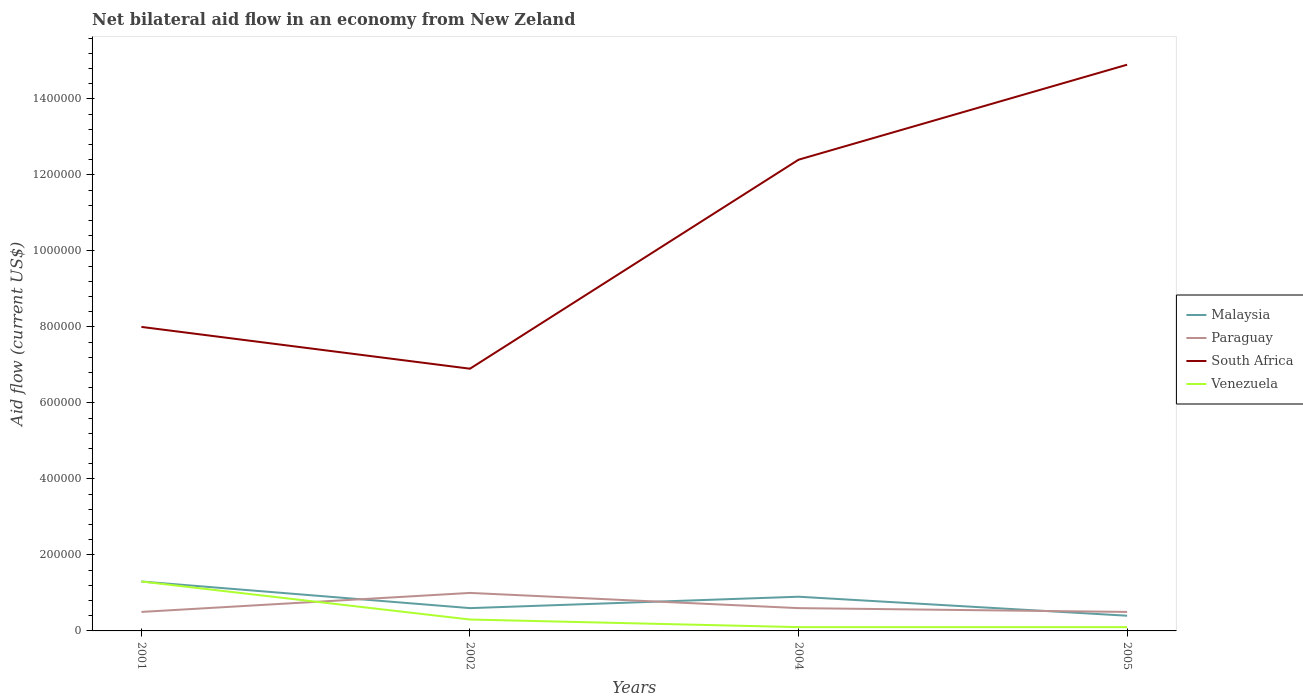Across all years, what is the maximum net bilateral aid flow in South Africa?
Give a very brief answer. 6.90e+05. What is the difference between the highest and the second highest net bilateral aid flow in Malaysia?
Ensure brevity in your answer.  9.00e+04. What is the difference between the highest and the lowest net bilateral aid flow in Paraguay?
Your answer should be very brief. 1. Is the net bilateral aid flow in Venezuela strictly greater than the net bilateral aid flow in Malaysia over the years?
Your response must be concise. No. How many years are there in the graph?
Your response must be concise. 4. Does the graph contain any zero values?
Offer a very short reply. No. Does the graph contain grids?
Offer a very short reply. No. Where does the legend appear in the graph?
Ensure brevity in your answer.  Center right. What is the title of the graph?
Your answer should be very brief. Net bilateral aid flow in an economy from New Zeland. What is the Aid flow (current US$) in Malaysia in 2001?
Offer a very short reply. 1.30e+05. What is the Aid flow (current US$) of Paraguay in 2001?
Your answer should be compact. 5.00e+04. What is the Aid flow (current US$) of South Africa in 2001?
Offer a terse response. 8.00e+05. What is the Aid flow (current US$) of Venezuela in 2001?
Your response must be concise. 1.30e+05. What is the Aid flow (current US$) in Malaysia in 2002?
Offer a very short reply. 6.00e+04. What is the Aid flow (current US$) in Paraguay in 2002?
Offer a very short reply. 1.00e+05. What is the Aid flow (current US$) in South Africa in 2002?
Your response must be concise. 6.90e+05. What is the Aid flow (current US$) of Venezuela in 2002?
Your answer should be compact. 3.00e+04. What is the Aid flow (current US$) in South Africa in 2004?
Make the answer very short. 1.24e+06. What is the Aid flow (current US$) of Venezuela in 2004?
Ensure brevity in your answer.  10000. What is the Aid flow (current US$) of Paraguay in 2005?
Your answer should be compact. 5.00e+04. What is the Aid flow (current US$) of South Africa in 2005?
Make the answer very short. 1.49e+06. What is the Aid flow (current US$) in Venezuela in 2005?
Keep it short and to the point. 10000. Across all years, what is the maximum Aid flow (current US$) of South Africa?
Keep it short and to the point. 1.49e+06. Across all years, what is the minimum Aid flow (current US$) in South Africa?
Make the answer very short. 6.90e+05. What is the total Aid flow (current US$) of Malaysia in the graph?
Keep it short and to the point. 3.20e+05. What is the total Aid flow (current US$) of Paraguay in the graph?
Make the answer very short. 2.60e+05. What is the total Aid flow (current US$) in South Africa in the graph?
Offer a very short reply. 4.22e+06. What is the total Aid flow (current US$) in Venezuela in the graph?
Your response must be concise. 1.80e+05. What is the difference between the Aid flow (current US$) in Venezuela in 2001 and that in 2002?
Provide a succinct answer. 1.00e+05. What is the difference between the Aid flow (current US$) in Paraguay in 2001 and that in 2004?
Provide a short and direct response. -10000. What is the difference between the Aid flow (current US$) in South Africa in 2001 and that in 2004?
Provide a short and direct response. -4.40e+05. What is the difference between the Aid flow (current US$) of Venezuela in 2001 and that in 2004?
Offer a terse response. 1.20e+05. What is the difference between the Aid flow (current US$) in South Africa in 2001 and that in 2005?
Provide a short and direct response. -6.90e+05. What is the difference between the Aid flow (current US$) of Venezuela in 2001 and that in 2005?
Ensure brevity in your answer.  1.20e+05. What is the difference between the Aid flow (current US$) in Paraguay in 2002 and that in 2004?
Your answer should be compact. 4.00e+04. What is the difference between the Aid flow (current US$) of South Africa in 2002 and that in 2004?
Make the answer very short. -5.50e+05. What is the difference between the Aid flow (current US$) in Venezuela in 2002 and that in 2004?
Your response must be concise. 2.00e+04. What is the difference between the Aid flow (current US$) in South Africa in 2002 and that in 2005?
Offer a very short reply. -8.00e+05. What is the difference between the Aid flow (current US$) in Malaysia in 2001 and the Aid flow (current US$) in Paraguay in 2002?
Provide a succinct answer. 3.00e+04. What is the difference between the Aid flow (current US$) of Malaysia in 2001 and the Aid flow (current US$) of South Africa in 2002?
Make the answer very short. -5.60e+05. What is the difference between the Aid flow (current US$) in Malaysia in 2001 and the Aid flow (current US$) in Venezuela in 2002?
Offer a very short reply. 1.00e+05. What is the difference between the Aid flow (current US$) in Paraguay in 2001 and the Aid flow (current US$) in South Africa in 2002?
Offer a terse response. -6.40e+05. What is the difference between the Aid flow (current US$) of Paraguay in 2001 and the Aid flow (current US$) of Venezuela in 2002?
Your answer should be very brief. 2.00e+04. What is the difference between the Aid flow (current US$) in South Africa in 2001 and the Aid flow (current US$) in Venezuela in 2002?
Offer a very short reply. 7.70e+05. What is the difference between the Aid flow (current US$) of Malaysia in 2001 and the Aid flow (current US$) of South Africa in 2004?
Provide a succinct answer. -1.11e+06. What is the difference between the Aid flow (current US$) in Paraguay in 2001 and the Aid flow (current US$) in South Africa in 2004?
Your answer should be compact. -1.19e+06. What is the difference between the Aid flow (current US$) in Paraguay in 2001 and the Aid flow (current US$) in Venezuela in 2004?
Offer a terse response. 4.00e+04. What is the difference between the Aid flow (current US$) in South Africa in 2001 and the Aid flow (current US$) in Venezuela in 2004?
Provide a short and direct response. 7.90e+05. What is the difference between the Aid flow (current US$) in Malaysia in 2001 and the Aid flow (current US$) in Paraguay in 2005?
Provide a succinct answer. 8.00e+04. What is the difference between the Aid flow (current US$) in Malaysia in 2001 and the Aid flow (current US$) in South Africa in 2005?
Make the answer very short. -1.36e+06. What is the difference between the Aid flow (current US$) in Malaysia in 2001 and the Aid flow (current US$) in Venezuela in 2005?
Provide a succinct answer. 1.20e+05. What is the difference between the Aid flow (current US$) of Paraguay in 2001 and the Aid flow (current US$) of South Africa in 2005?
Provide a succinct answer. -1.44e+06. What is the difference between the Aid flow (current US$) of Paraguay in 2001 and the Aid flow (current US$) of Venezuela in 2005?
Your answer should be very brief. 4.00e+04. What is the difference between the Aid flow (current US$) of South Africa in 2001 and the Aid flow (current US$) of Venezuela in 2005?
Ensure brevity in your answer.  7.90e+05. What is the difference between the Aid flow (current US$) in Malaysia in 2002 and the Aid flow (current US$) in South Africa in 2004?
Your answer should be very brief. -1.18e+06. What is the difference between the Aid flow (current US$) in Paraguay in 2002 and the Aid flow (current US$) in South Africa in 2004?
Your answer should be compact. -1.14e+06. What is the difference between the Aid flow (current US$) of South Africa in 2002 and the Aid flow (current US$) of Venezuela in 2004?
Your answer should be compact. 6.80e+05. What is the difference between the Aid flow (current US$) in Malaysia in 2002 and the Aid flow (current US$) in South Africa in 2005?
Give a very brief answer. -1.43e+06. What is the difference between the Aid flow (current US$) in Malaysia in 2002 and the Aid flow (current US$) in Venezuela in 2005?
Your response must be concise. 5.00e+04. What is the difference between the Aid flow (current US$) in Paraguay in 2002 and the Aid flow (current US$) in South Africa in 2005?
Provide a short and direct response. -1.39e+06. What is the difference between the Aid flow (current US$) in Paraguay in 2002 and the Aid flow (current US$) in Venezuela in 2005?
Provide a succinct answer. 9.00e+04. What is the difference between the Aid flow (current US$) of South Africa in 2002 and the Aid flow (current US$) of Venezuela in 2005?
Provide a succinct answer. 6.80e+05. What is the difference between the Aid flow (current US$) of Malaysia in 2004 and the Aid flow (current US$) of Paraguay in 2005?
Provide a short and direct response. 4.00e+04. What is the difference between the Aid flow (current US$) in Malaysia in 2004 and the Aid flow (current US$) in South Africa in 2005?
Provide a succinct answer. -1.40e+06. What is the difference between the Aid flow (current US$) in Paraguay in 2004 and the Aid flow (current US$) in South Africa in 2005?
Offer a very short reply. -1.43e+06. What is the difference between the Aid flow (current US$) in South Africa in 2004 and the Aid flow (current US$) in Venezuela in 2005?
Give a very brief answer. 1.23e+06. What is the average Aid flow (current US$) of Malaysia per year?
Offer a very short reply. 8.00e+04. What is the average Aid flow (current US$) of Paraguay per year?
Ensure brevity in your answer.  6.50e+04. What is the average Aid flow (current US$) of South Africa per year?
Offer a terse response. 1.06e+06. What is the average Aid flow (current US$) of Venezuela per year?
Offer a terse response. 4.50e+04. In the year 2001, what is the difference between the Aid flow (current US$) in Malaysia and Aid flow (current US$) in Paraguay?
Offer a very short reply. 8.00e+04. In the year 2001, what is the difference between the Aid flow (current US$) in Malaysia and Aid flow (current US$) in South Africa?
Make the answer very short. -6.70e+05. In the year 2001, what is the difference between the Aid flow (current US$) of Paraguay and Aid flow (current US$) of South Africa?
Offer a terse response. -7.50e+05. In the year 2001, what is the difference between the Aid flow (current US$) in Paraguay and Aid flow (current US$) in Venezuela?
Make the answer very short. -8.00e+04. In the year 2001, what is the difference between the Aid flow (current US$) in South Africa and Aid flow (current US$) in Venezuela?
Give a very brief answer. 6.70e+05. In the year 2002, what is the difference between the Aid flow (current US$) in Malaysia and Aid flow (current US$) in South Africa?
Make the answer very short. -6.30e+05. In the year 2002, what is the difference between the Aid flow (current US$) in Malaysia and Aid flow (current US$) in Venezuela?
Make the answer very short. 3.00e+04. In the year 2002, what is the difference between the Aid flow (current US$) in Paraguay and Aid flow (current US$) in South Africa?
Offer a very short reply. -5.90e+05. In the year 2004, what is the difference between the Aid flow (current US$) of Malaysia and Aid flow (current US$) of South Africa?
Your answer should be very brief. -1.15e+06. In the year 2004, what is the difference between the Aid flow (current US$) in Malaysia and Aid flow (current US$) in Venezuela?
Make the answer very short. 8.00e+04. In the year 2004, what is the difference between the Aid flow (current US$) in Paraguay and Aid flow (current US$) in South Africa?
Your answer should be very brief. -1.18e+06. In the year 2004, what is the difference between the Aid flow (current US$) in South Africa and Aid flow (current US$) in Venezuela?
Provide a succinct answer. 1.23e+06. In the year 2005, what is the difference between the Aid flow (current US$) in Malaysia and Aid flow (current US$) in Paraguay?
Make the answer very short. -10000. In the year 2005, what is the difference between the Aid flow (current US$) of Malaysia and Aid flow (current US$) of South Africa?
Your response must be concise. -1.45e+06. In the year 2005, what is the difference between the Aid flow (current US$) in Paraguay and Aid flow (current US$) in South Africa?
Your response must be concise. -1.44e+06. In the year 2005, what is the difference between the Aid flow (current US$) of Paraguay and Aid flow (current US$) of Venezuela?
Your answer should be compact. 4.00e+04. In the year 2005, what is the difference between the Aid flow (current US$) in South Africa and Aid flow (current US$) in Venezuela?
Give a very brief answer. 1.48e+06. What is the ratio of the Aid flow (current US$) of Malaysia in 2001 to that in 2002?
Ensure brevity in your answer.  2.17. What is the ratio of the Aid flow (current US$) of Paraguay in 2001 to that in 2002?
Offer a terse response. 0.5. What is the ratio of the Aid flow (current US$) of South Africa in 2001 to that in 2002?
Offer a terse response. 1.16. What is the ratio of the Aid flow (current US$) of Venezuela in 2001 to that in 2002?
Provide a short and direct response. 4.33. What is the ratio of the Aid flow (current US$) in Malaysia in 2001 to that in 2004?
Your answer should be compact. 1.44. What is the ratio of the Aid flow (current US$) in South Africa in 2001 to that in 2004?
Provide a succinct answer. 0.65. What is the ratio of the Aid flow (current US$) in Venezuela in 2001 to that in 2004?
Your answer should be very brief. 13. What is the ratio of the Aid flow (current US$) of Paraguay in 2001 to that in 2005?
Your answer should be very brief. 1. What is the ratio of the Aid flow (current US$) of South Africa in 2001 to that in 2005?
Provide a succinct answer. 0.54. What is the ratio of the Aid flow (current US$) of Venezuela in 2001 to that in 2005?
Keep it short and to the point. 13. What is the ratio of the Aid flow (current US$) of South Africa in 2002 to that in 2004?
Provide a short and direct response. 0.56. What is the ratio of the Aid flow (current US$) of South Africa in 2002 to that in 2005?
Your answer should be compact. 0.46. What is the ratio of the Aid flow (current US$) of Venezuela in 2002 to that in 2005?
Ensure brevity in your answer.  3. What is the ratio of the Aid flow (current US$) of Malaysia in 2004 to that in 2005?
Provide a short and direct response. 2.25. What is the ratio of the Aid flow (current US$) in South Africa in 2004 to that in 2005?
Keep it short and to the point. 0.83. What is the ratio of the Aid flow (current US$) of Venezuela in 2004 to that in 2005?
Your response must be concise. 1. What is the difference between the highest and the second highest Aid flow (current US$) of Paraguay?
Your response must be concise. 4.00e+04. What is the difference between the highest and the lowest Aid flow (current US$) of South Africa?
Make the answer very short. 8.00e+05. What is the difference between the highest and the lowest Aid flow (current US$) in Venezuela?
Make the answer very short. 1.20e+05. 